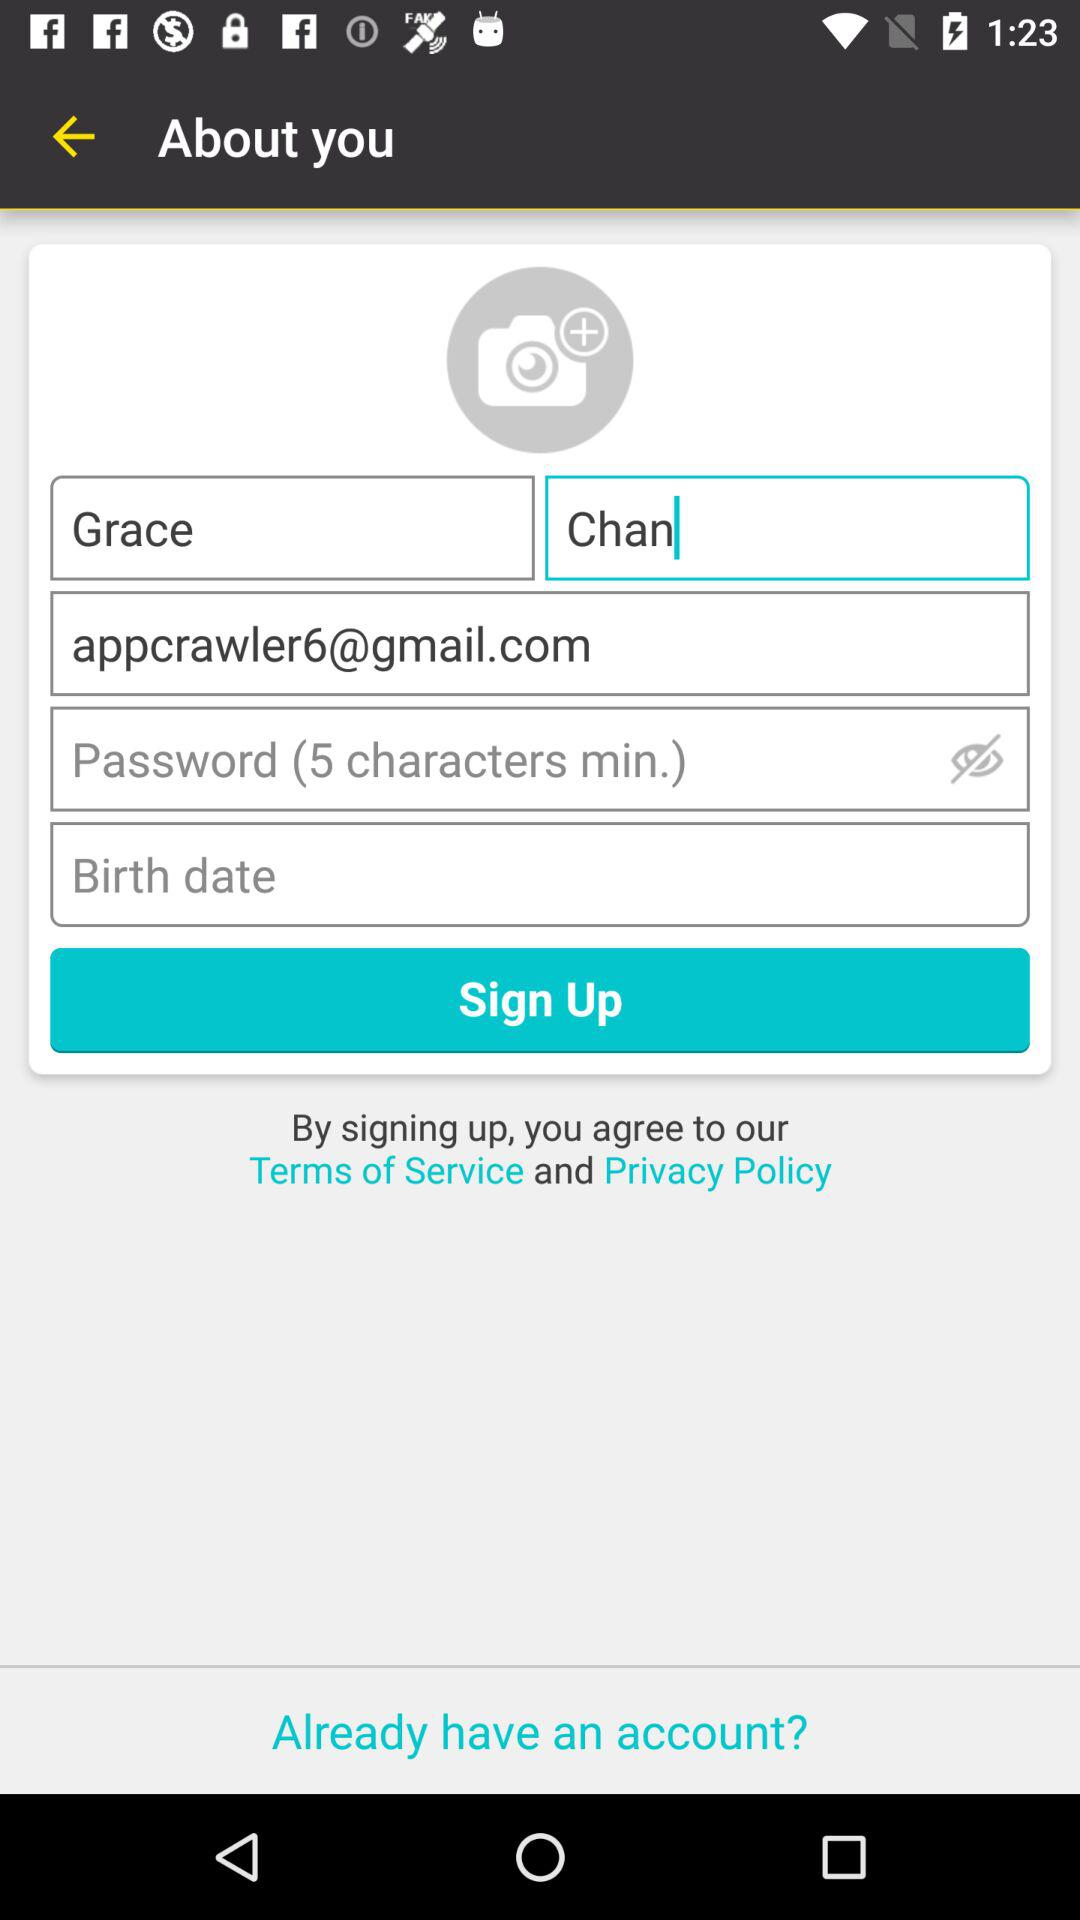What is the person name? The person name is Grace Chan. 